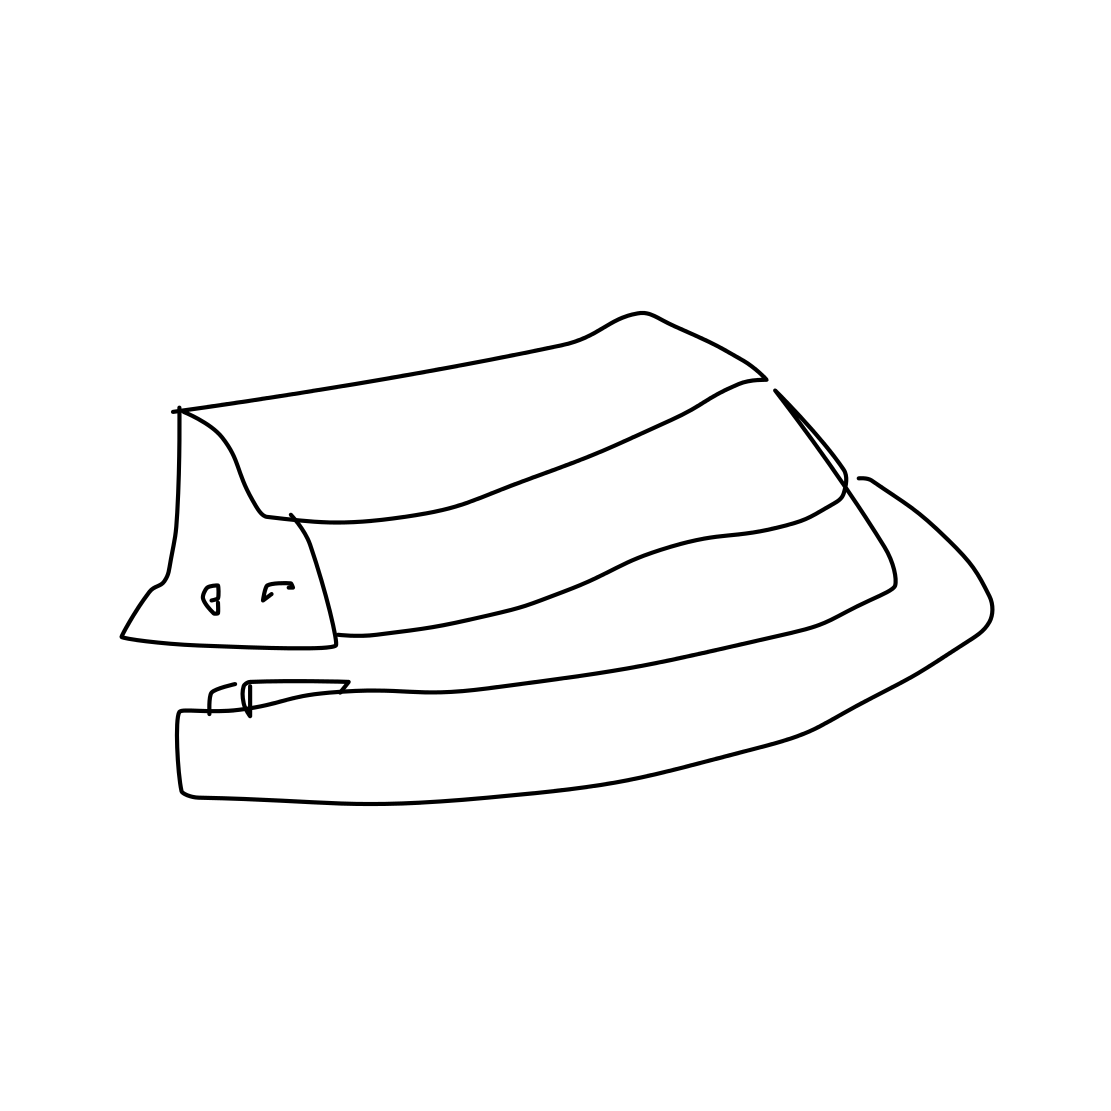Could you describe the style or era this hat might be associated with? The hat style depicted is often associated with the early to mid-20th century. It evokes a sense of vintage fashion, commonly worn by men during the 1920s through the 1950s. 